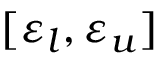Convert formula to latex. <formula><loc_0><loc_0><loc_500><loc_500>[ \varepsilon _ { l } , \varepsilon _ { u } ]</formula> 